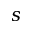Convert formula to latex. <formula><loc_0><loc_0><loc_500><loc_500>s</formula> 